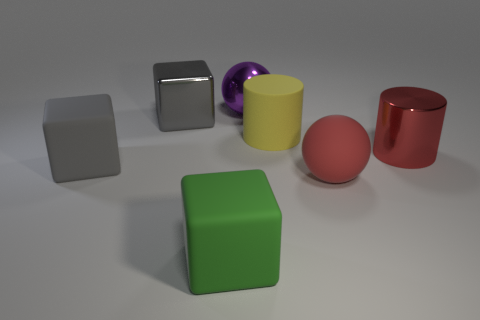Does the red metal cylinder have the same size as the purple metal thing?
Offer a very short reply. Yes. What is the color of the metal block that is the same size as the yellow thing?
Provide a succinct answer. Gray. There is a red sphere; is its size the same as the gray thing in front of the metal cube?
Offer a terse response. Yes. What number of large metallic balls have the same color as the matte ball?
Provide a short and direct response. 0. How many objects are either gray things or large matte blocks behind the green object?
Keep it short and to the point. 2. Is there a large red cylinder that has the same material as the large green cube?
Ensure brevity in your answer.  No. The large red rubber object is what shape?
Offer a very short reply. Sphere. The rubber thing behind the gray thing that is in front of the big red metal thing is what shape?
Make the answer very short. Cylinder. How many other objects are there of the same shape as the green matte object?
Your answer should be compact. 2. There is a metal object in front of the shiny thing that is on the left side of the purple object; what size is it?
Give a very brief answer. Large. 